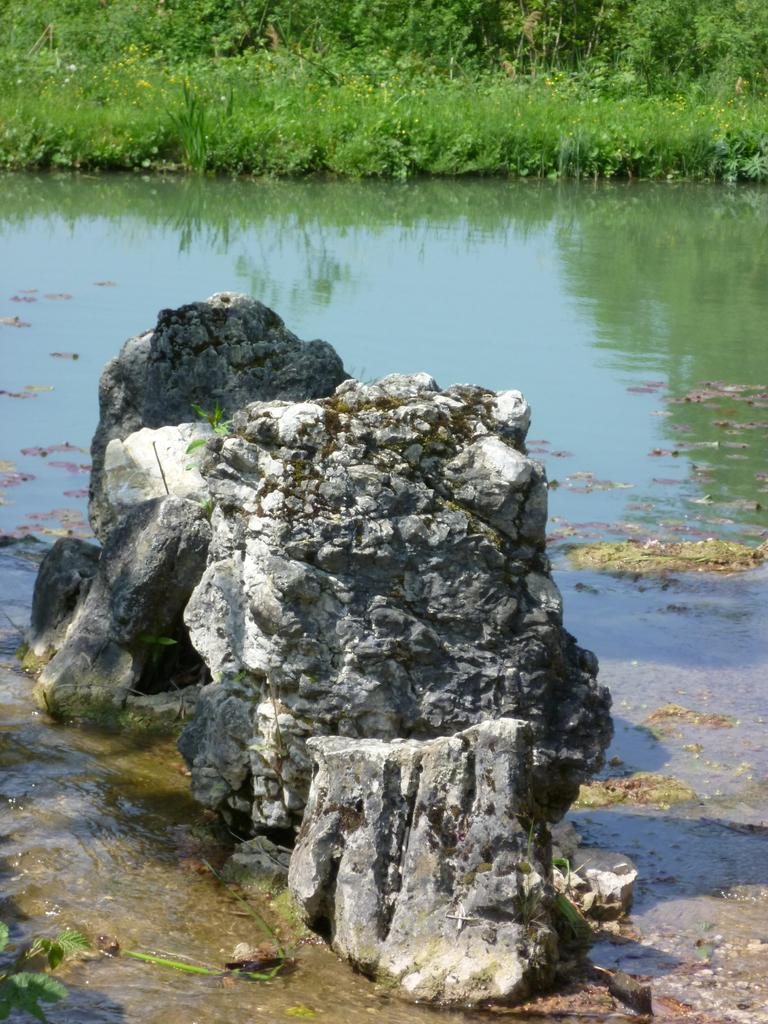What type of natural elements can be seen in the image? There are stones and water visible in the image. What can be seen in the background of the image? There is grass and plants in the background of the image. What type of verse is being recited by the masked figure in the image? There is no masked figure or verse present in the image; it features stones, water, grass, and plants. 